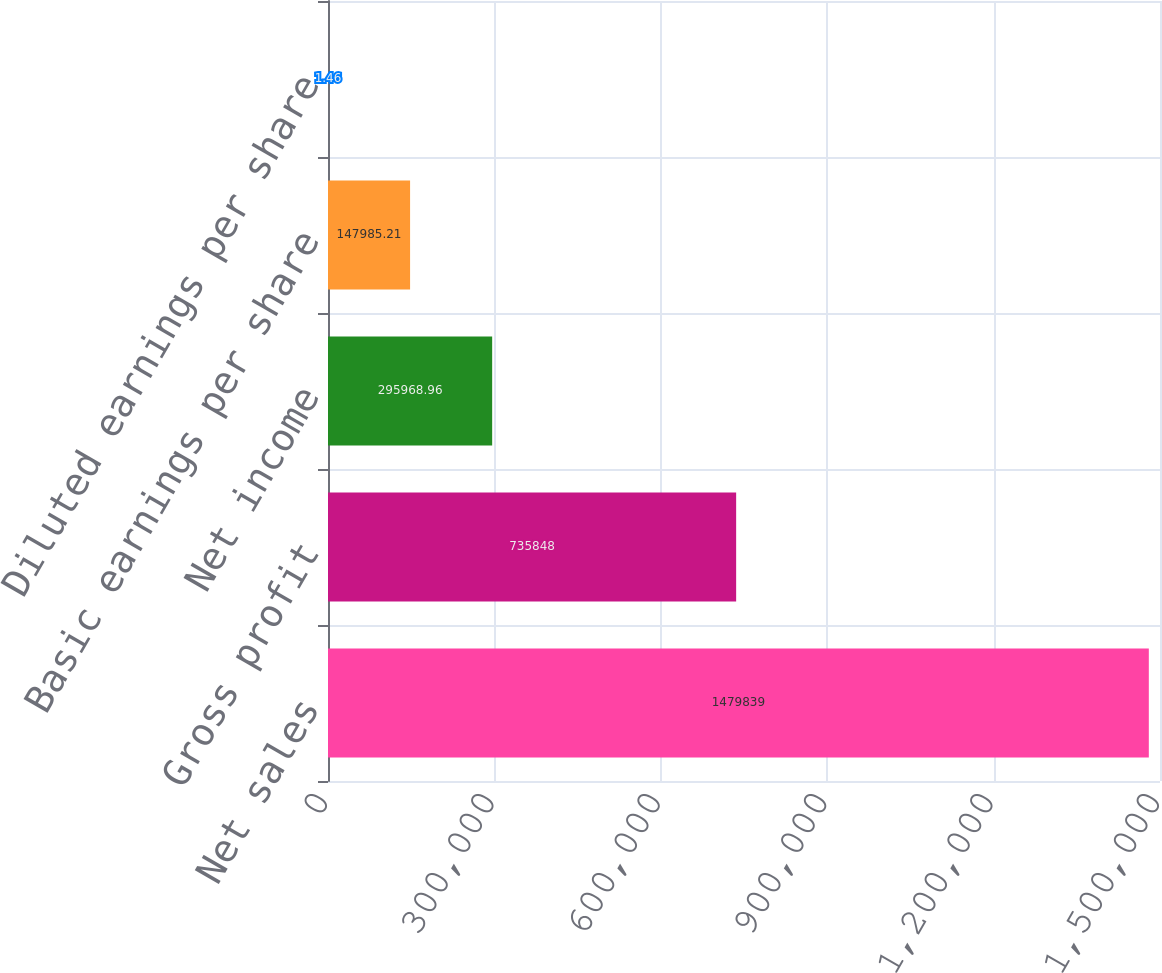<chart> <loc_0><loc_0><loc_500><loc_500><bar_chart><fcel>Net sales<fcel>Gross profit<fcel>Net income<fcel>Basic earnings per share<fcel>Diluted earnings per share<nl><fcel>1.47984e+06<fcel>735848<fcel>295969<fcel>147985<fcel>1.46<nl></chart> 